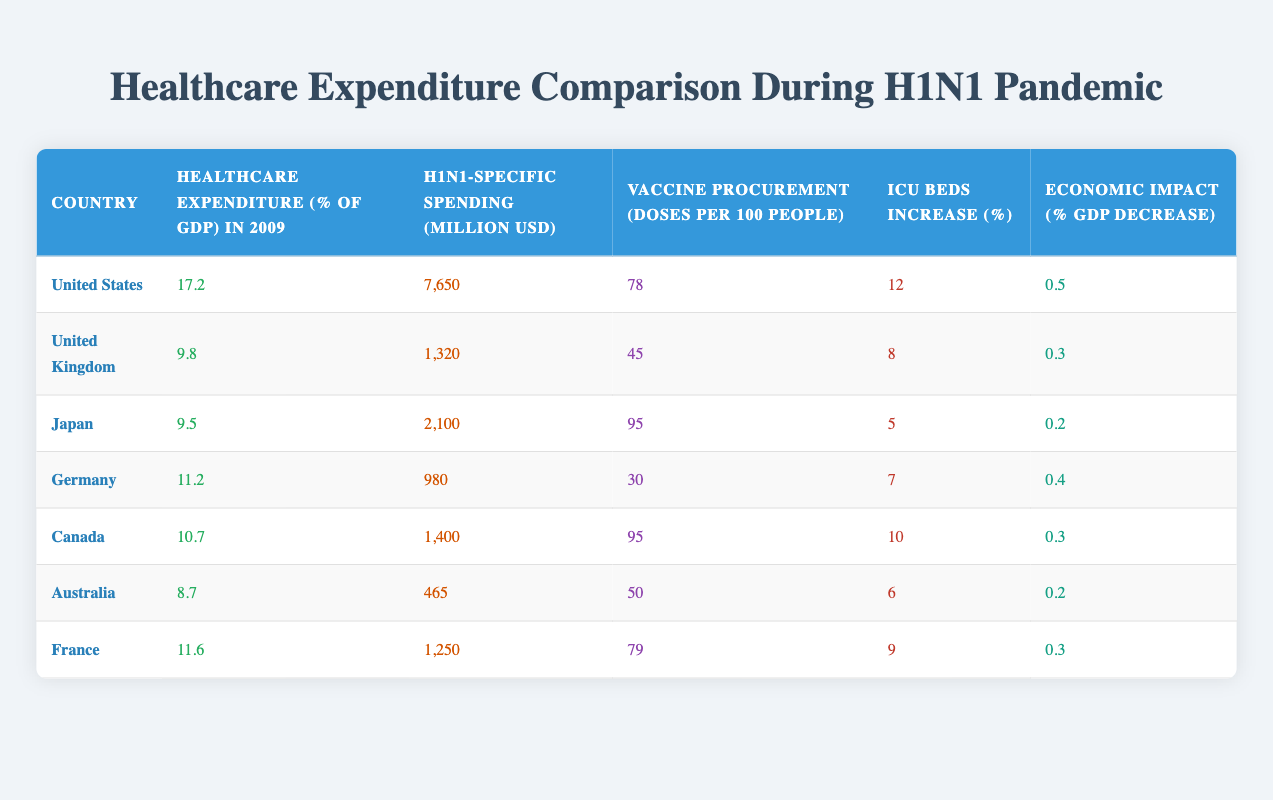What country had the highest healthcare expenditure as a percentage of GDP in 2009? By examining the "Healthcare expenditure (% of GDP) in 2009" column, the United States shows a value of 17.2, which is higher than all other countries listed.
Answer: United States Which country spent the least on H1N1-specific spending in million USD? Looking at the "H1N1-specific spending (million USD)" column, Australia has the lowest spending at 465 million USD.
Answer: Australia What is the average vaccination dose procurement (doses per 100 people) across all listed countries? To find the average, add the values from the "Vaccine procurement (doses per 100 people)" column: (78 + 45 + 95 + 30 + 95 + 50 + 79) = 472. There are 7 countries, so the average is 472/7 = 67.43.
Answer: 67.43 Did Japan have a higher percentage increase in ICU beds compared to Canada? Japan had a 5% increase in ICU beds, while Canada had a 10% increase. Since 10% is greater than 5%, the statement is false.
Answer: No Which country experienced the least economic impact due to H1N1, measured as a percentage GDP decrease? By checking the "Economic impact (% GDP decrease)" column, Japan shows a decrease of 0.2%, the smallest among the countries listed.
Answer: Japan How many more doses of vaccine per 100 people were procured by the United States compared to Germany? The United States procured 78 doses per 100 people and Germany procured 30 doses. The difference is 78 - 30 = 48 doses.
Answer: 48 doses Which country had a higher healthcare expenditure as a percentage of GDP: France or Germany? France had an expenditure of 11.6% while Germany had 11.2%. Since 11.6% is greater than 11.2%, France had the higher expenditure.
Answer: France Is it true that the United States had an economic impact more than 0.5% decrease in GDP? The economic impact for the United States is recorded as 0.5%, so it did not exceed that value. Thus, the statement is false.
Answer: No What is the total H1N1-specific spending (in million USD) for the countries with healthcare expenditure greater than 10% of GDP? The countries with greater than 10% are the United States (7650), Germany (980), and France (1250). Total spending is 7650 + 980 + 1250 = 9880 million USD.
Answer: 9880 million USD 